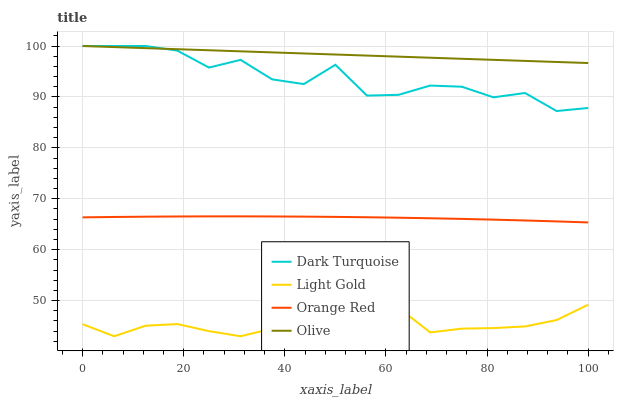Does Dark Turquoise have the minimum area under the curve?
Answer yes or no. No. Does Dark Turquoise have the maximum area under the curve?
Answer yes or no. No. Is Light Gold the smoothest?
Answer yes or no. No. Is Light Gold the roughest?
Answer yes or no. No. Does Dark Turquoise have the lowest value?
Answer yes or no. No. Does Light Gold have the highest value?
Answer yes or no. No. Is Orange Red less than Olive?
Answer yes or no. Yes. Is Dark Turquoise greater than Orange Red?
Answer yes or no. Yes. Does Orange Red intersect Olive?
Answer yes or no. No. 